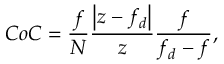<formula> <loc_0><loc_0><loc_500><loc_500>C o C = \frac { f } { N } \frac { \left | z - f _ { d } \right | } { z } \frac { f } { f _ { d } - f } ,</formula> 